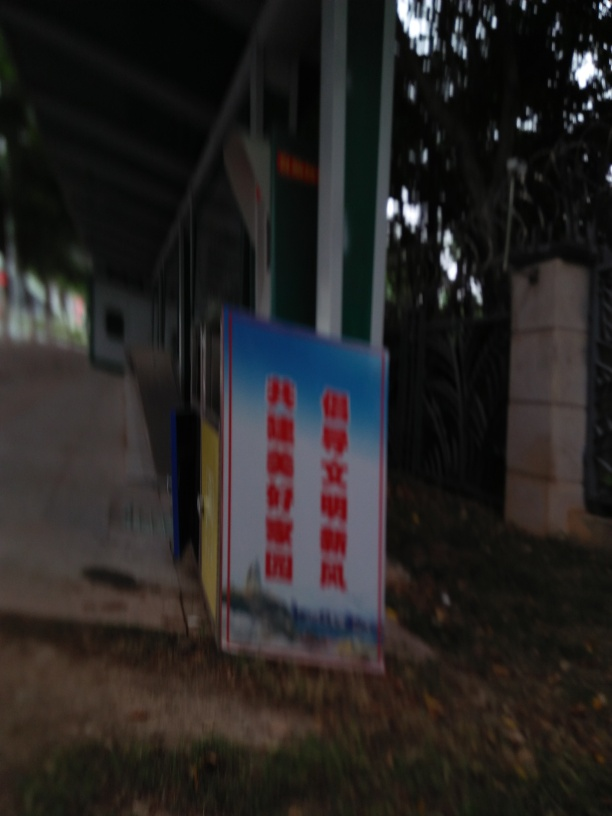Is there anything about the surroundings that can give us a clue about the location or context of this signage? The background reveals a fenced area with vegetation, suggesting an outdoor environment possibly near a park or a recreational area. The structure in the distance appears to be a pavilion or a shelter, which might indicate that the sign is near a public facility or entrance where such informative signs are typically found. Could the colors on the sign hint at what type of information it is conveying? Colors are often used to grab attention or convey specific messages. While the exact text is unreadable, the use of bold red and blue colors might suggest important information or warnings, which are urgency-related hues. Alternatively, they might represent corporate or brand colors if the sign is for advertising purposes. 